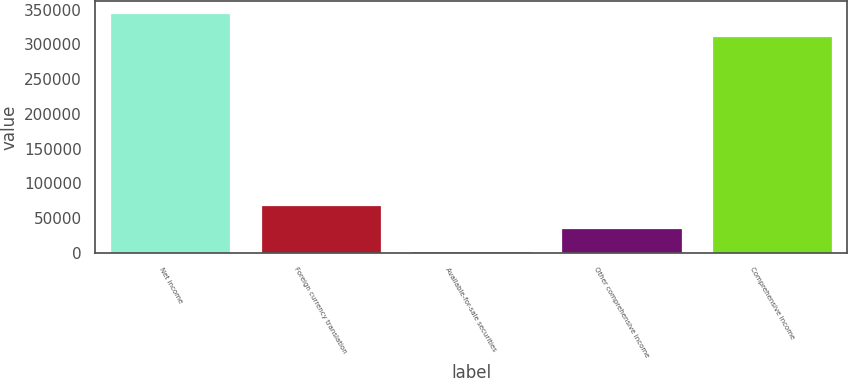Convert chart to OTSL. <chart><loc_0><loc_0><loc_500><loc_500><bar_chart><fcel>Net income<fcel>Foreign currency translation<fcel>Available-for-sale securities<fcel>Other comprehensive income<fcel>Comprehensive income<nl><fcel>345520<fcel>68719.4<fcel>2440<fcel>35579.7<fcel>312380<nl></chart> 